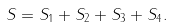Convert formula to latex. <formula><loc_0><loc_0><loc_500><loc_500>S = S _ { 1 } + S _ { 2 } + S _ { 3 } + S _ { 4 } .</formula> 